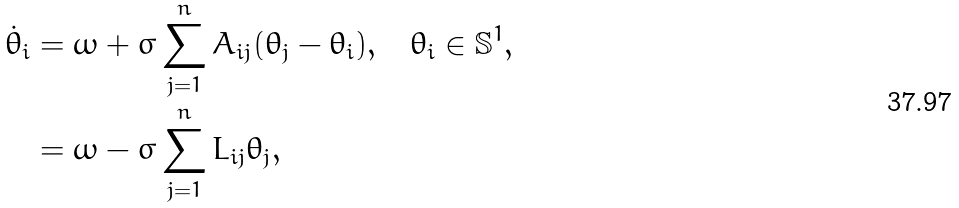Convert formula to latex. <formula><loc_0><loc_0><loc_500><loc_500>\dot { \theta } _ { i } & = \omega + \sigma \sum _ { j = 1 } ^ { n } A _ { i j } ( \theta _ { j } - \theta _ { i } ) , \quad \theta _ { i } \in \mathbb { S } ^ { 1 } , \\ & = \omega - \sigma \sum _ { j = 1 } ^ { n } L _ { i j } \theta _ { j } ,</formula> 